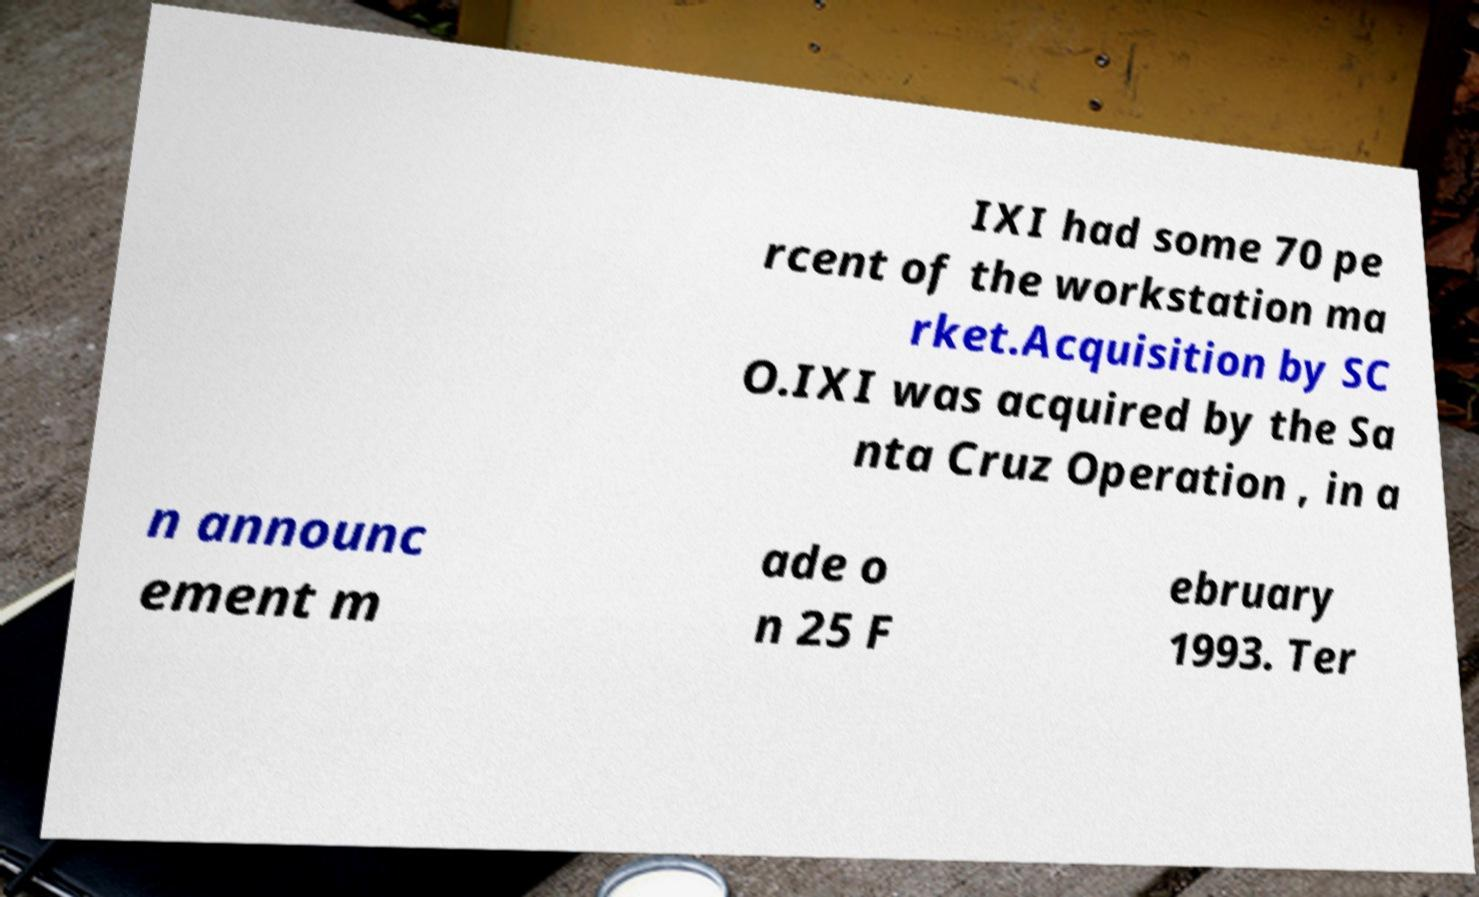I need the written content from this picture converted into text. Can you do that? IXI had some 70 pe rcent of the workstation ma rket.Acquisition by SC O.IXI was acquired by the Sa nta Cruz Operation , in a n announc ement m ade o n 25 F ebruary 1993. Ter 